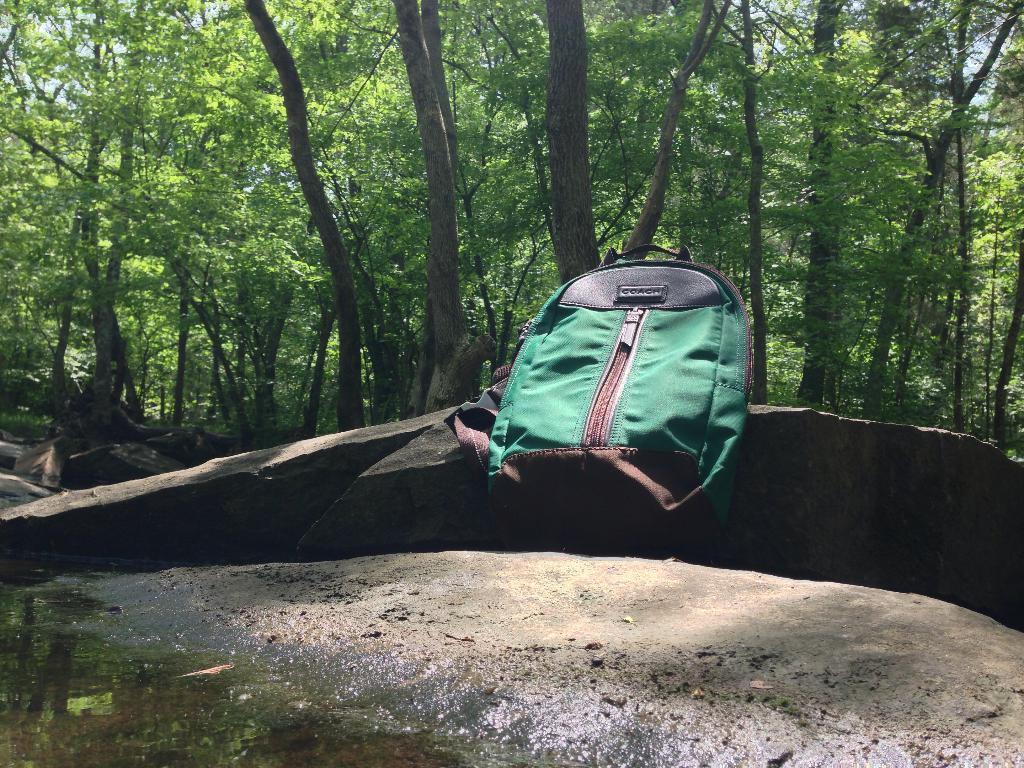Can you describe this image briefly? In the image there is a bag on a rock and in behind there are trees. 